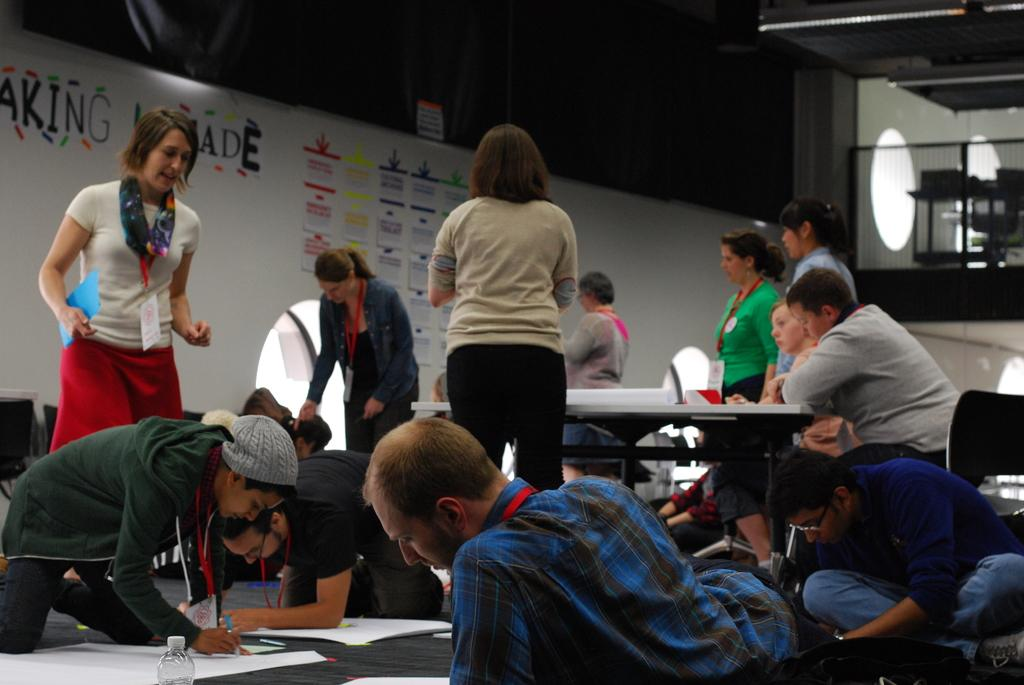Where is the image taken? The image is taken in a room. What are the people in the image doing? The people are sitting on the floor and drawing on paper. Are there any people standing in the image? Yes, some people are standing in the image. What can be seen in the background of the image? There is a banner in the background. What type of hook is hanging from the ceiling in the image? There is no hook hanging from the ceiling in the image. Can you tell me how many airplanes are visible in the image? There are no airplanes visible in the image; it is taken in a room where people are drawing on paper. 